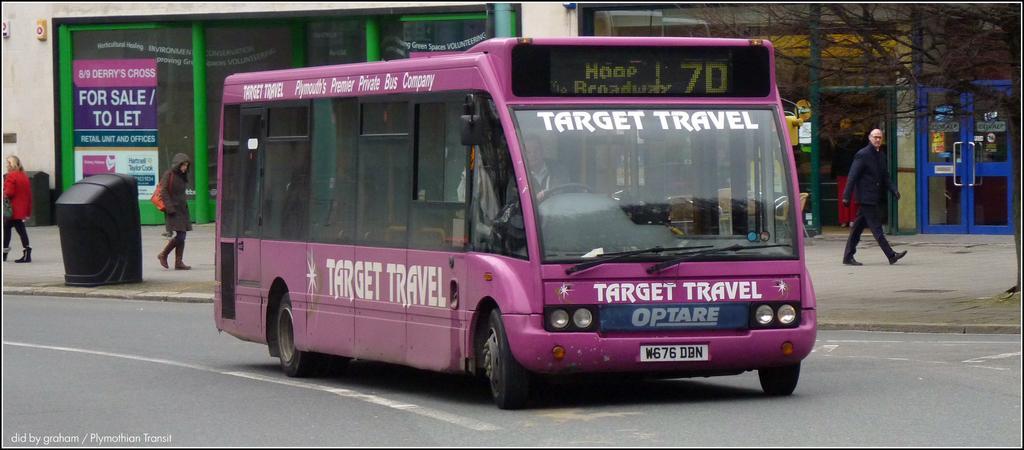Could you give a brief overview of what you see in this image? At the bottom of the image there is a road with bus. Behind the bus there is a footpath with few people and also there is a black object. On the right side of the image there is a tree without leaves. In the background there is a building with glass door and posters on the glass doors. 